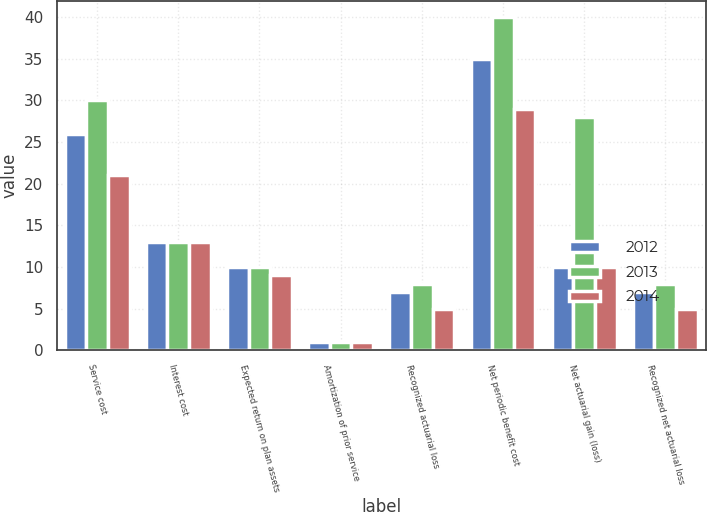Convert chart to OTSL. <chart><loc_0><loc_0><loc_500><loc_500><stacked_bar_chart><ecel><fcel>Service cost<fcel>Interest cost<fcel>Expected return on plan assets<fcel>Amortization of prior service<fcel>Recognized actuarial loss<fcel>Net periodic benefit cost<fcel>Net actuarial gain (loss)<fcel>Recognized net actuarial loss<nl><fcel>2012<fcel>26<fcel>13<fcel>10<fcel>1<fcel>7<fcel>35<fcel>10<fcel>7<nl><fcel>2013<fcel>30<fcel>13<fcel>10<fcel>1<fcel>8<fcel>40<fcel>28<fcel>8<nl><fcel>2014<fcel>21<fcel>13<fcel>9<fcel>1<fcel>5<fcel>29<fcel>10<fcel>5<nl></chart> 